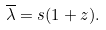Convert formula to latex. <formula><loc_0><loc_0><loc_500><loc_500>\overline { \lambda } = s ( 1 + z ) .</formula> 